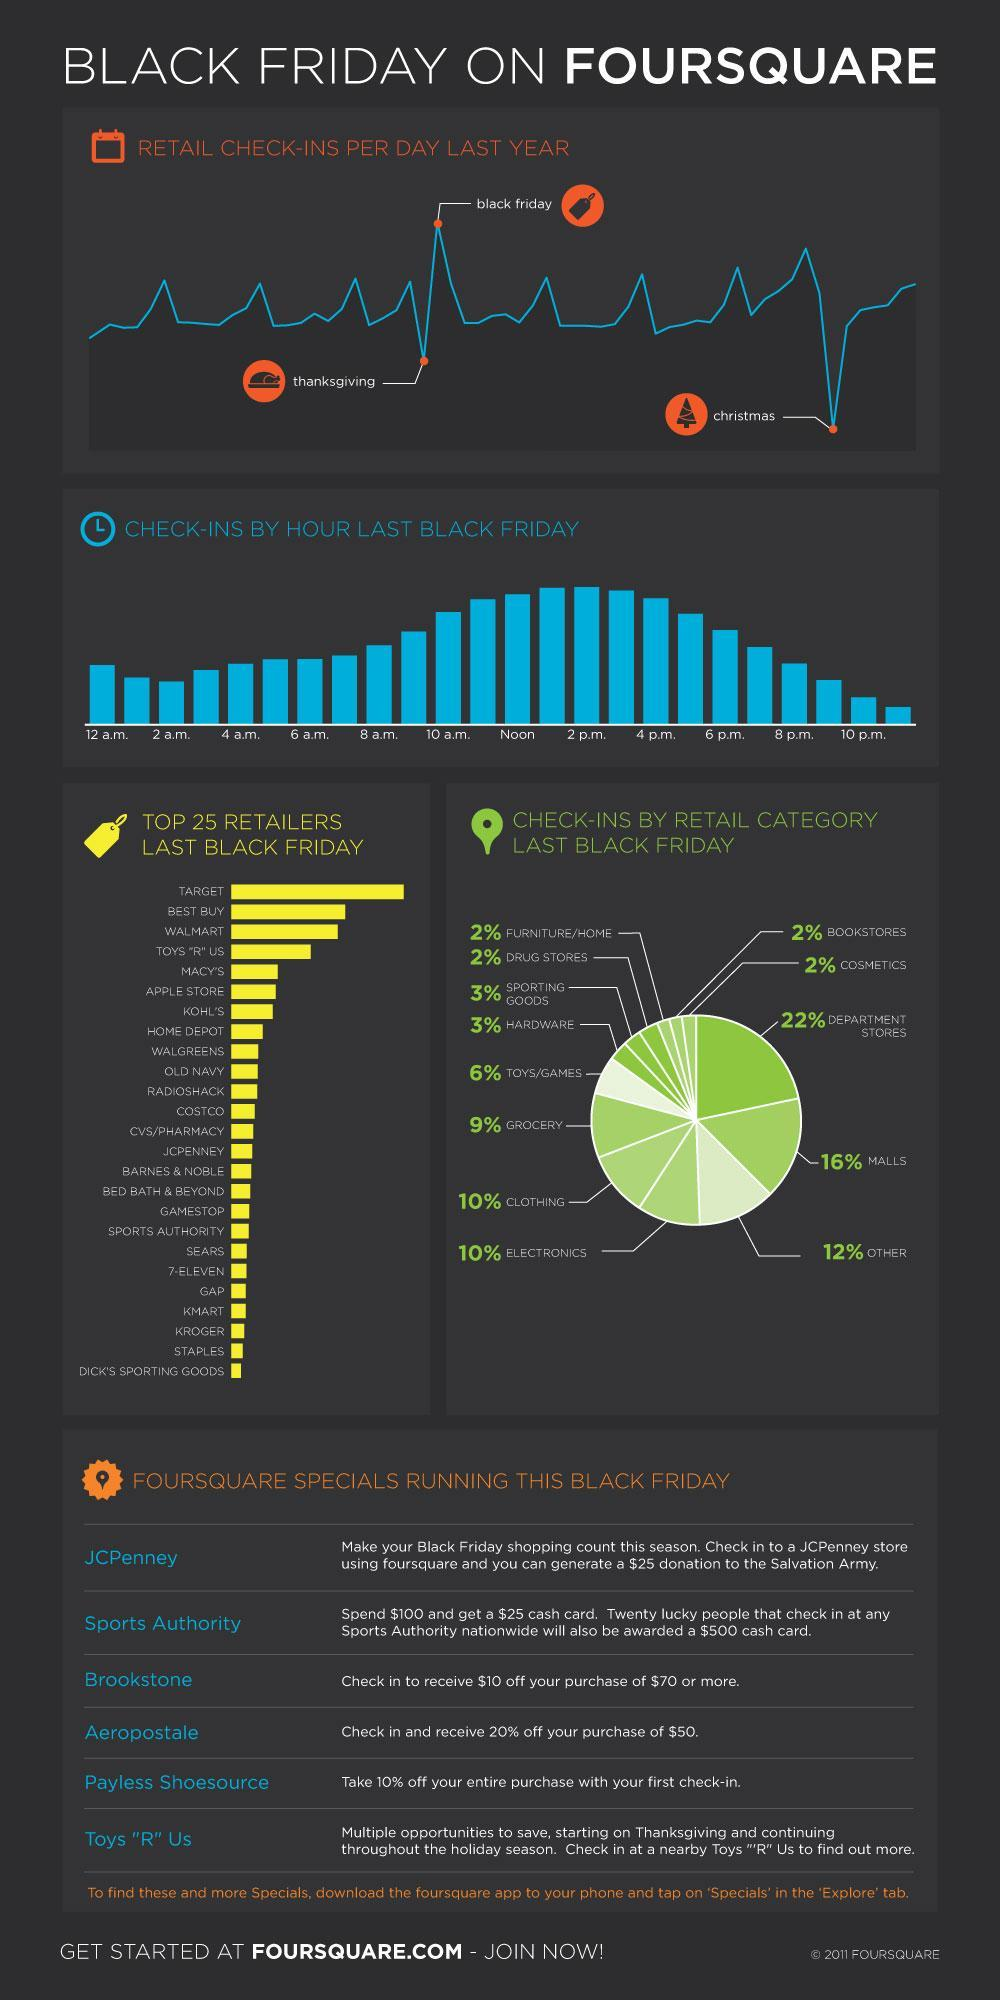What is the discount obtained if a person makes a purchase of $100 from Brookstone?
Answer the question with a short phrase. $10 Which of the three shopping seasons show a maximum dip in retail check-ins ? Christmas Which retailer clocked the highest sales on Black Friday? Target What was the time that had lowest check-ins for Black Friday? 11 p.m. What is the difference in check-ins between Department Stores and Malls? 6% What the total percentage of check-ins for clothing and electronics? 20% How many stores are running four square specials this Black Friday? 6 